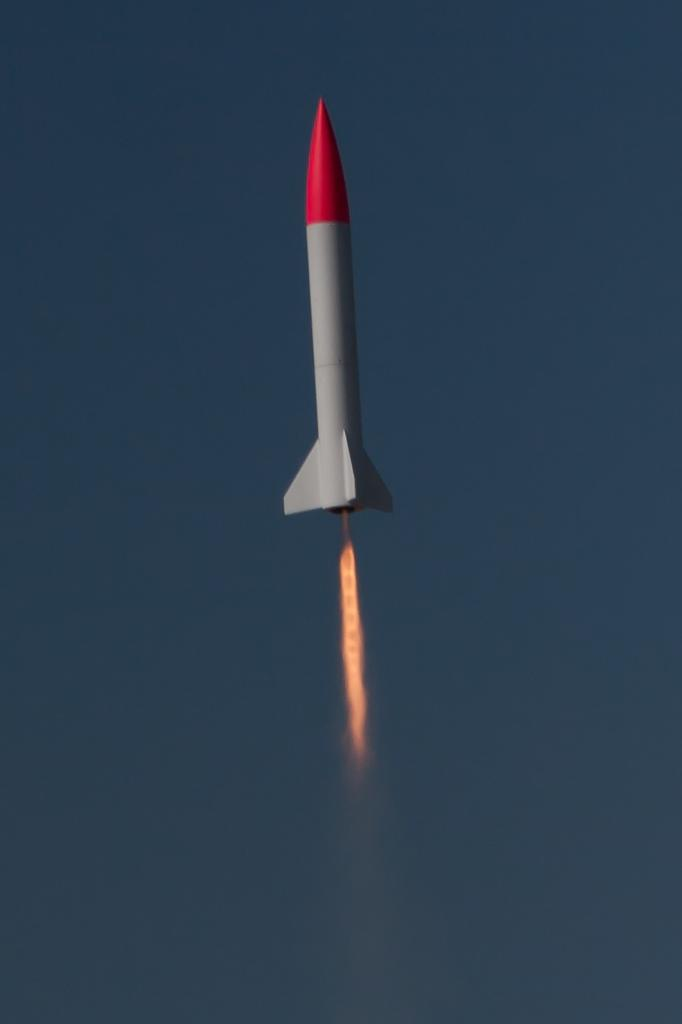What is the main subject of the image? The main subject of the image is a rocket. What is the rocket doing in the image? The rocket is moving in the air. What colors can be seen on the rocket? The rocket is in grey and red color. What is associated with the rocket that indicates it is in motion? There is fire associated with the rocket. What type of thread is being used to sew the wings of the birds in the image? There are no birds or wings present in the image, so there is no thread being used for sewing. 